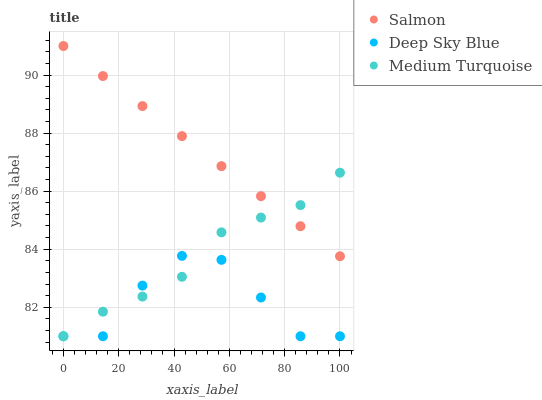Does Deep Sky Blue have the minimum area under the curve?
Answer yes or no. Yes. Does Salmon have the maximum area under the curve?
Answer yes or no. Yes. Does Medium Turquoise have the minimum area under the curve?
Answer yes or no. No. Does Medium Turquoise have the maximum area under the curve?
Answer yes or no. No. Is Salmon the smoothest?
Answer yes or no. Yes. Is Deep Sky Blue the roughest?
Answer yes or no. Yes. Is Medium Turquoise the smoothest?
Answer yes or no. No. Is Medium Turquoise the roughest?
Answer yes or no. No. Does Medium Turquoise have the lowest value?
Answer yes or no. Yes. Does Salmon have the highest value?
Answer yes or no. Yes. Does Medium Turquoise have the highest value?
Answer yes or no. No. Is Deep Sky Blue less than Salmon?
Answer yes or no. Yes. Is Salmon greater than Deep Sky Blue?
Answer yes or no. Yes. Does Medium Turquoise intersect Deep Sky Blue?
Answer yes or no. Yes. Is Medium Turquoise less than Deep Sky Blue?
Answer yes or no. No. Is Medium Turquoise greater than Deep Sky Blue?
Answer yes or no. No. Does Deep Sky Blue intersect Salmon?
Answer yes or no. No. 